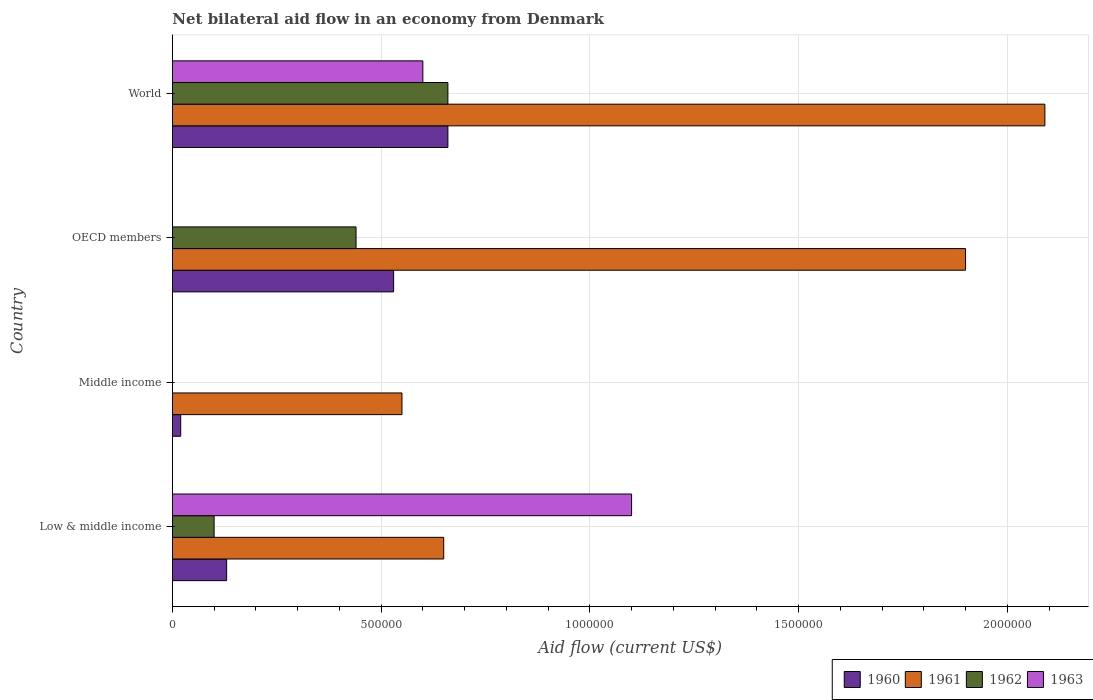How many different coloured bars are there?
Provide a succinct answer. 4. Are the number of bars on each tick of the Y-axis equal?
Provide a short and direct response. No. What is the total net bilateral aid flow in 1962 in the graph?
Your answer should be compact. 1.20e+06. What is the difference between the net bilateral aid flow in 1962 in OECD members and that in World?
Your response must be concise. -2.20e+05. What is the difference between the net bilateral aid flow in 1963 in OECD members and the net bilateral aid flow in 1961 in Middle income?
Your answer should be very brief. -5.50e+05. What is the average net bilateral aid flow in 1961 per country?
Provide a short and direct response. 1.30e+06. What is the difference between the net bilateral aid flow in 1963 and net bilateral aid flow in 1961 in World?
Offer a terse response. -1.49e+06. In how many countries, is the net bilateral aid flow in 1961 greater than 300000 US$?
Make the answer very short. 4. What is the ratio of the net bilateral aid flow in 1961 in Low & middle income to that in Middle income?
Offer a terse response. 1.18. Is the net bilateral aid flow in 1961 in Middle income less than that in World?
Keep it short and to the point. Yes. What is the difference between the highest and the second highest net bilateral aid flow in 1962?
Your answer should be very brief. 2.20e+05. What is the difference between the highest and the lowest net bilateral aid flow in 1960?
Your answer should be very brief. 6.40e+05. In how many countries, is the net bilateral aid flow in 1961 greater than the average net bilateral aid flow in 1961 taken over all countries?
Your response must be concise. 2. Is the sum of the net bilateral aid flow in 1961 in Low & middle income and World greater than the maximum net bilateral aid flow in 1962 across all countries?
Offer a very short reply. Yes. Is it the case that in every country, the sum of the net bilateral aid flow in 1963 and net bilateral aid flow in 1960 is greater than the sum of net bilateral aid flow in 1962 and net bilateral aid flow in 1961?
Give a very brief answer. No. How many countries are there in the graph?
Your answer should be very brief. 4. Are the values on the major ticks of X-axis written in scientific E-notation?
Provide a short and direct response. No. Does the graph contain any zero values?
Offer a terse response. Yes. What is the title of the graph?
Offer a terse response. Net bilateral aid flow in an economy from Denmark. What is the label or title of the Y-axis?
Provide a succinct answer. Country. What is the Aid flow (current US$) of 1960 in Low & middle income?
Ensure brevity in your answer.  1.30e+05. What is the Aid flow (current US$) in 1961 in Low & middle income?
Provide a succinct answer. 6.50e+05. What is the Aid flow (current US$) in 1963 in Low & middle income?
Your answer should be very brief. 1.10e+06. What is the Aid flow (current US$) of 1962 in Middle income?
Provide a succinct answer. 0. What is the Aid flow (current US$) of 1960 in OECD members?
Provide a succinct answer. 5.30e+05. What is the Aid flow (current US$) of 1961 in OECD members?
Keep it short and to the point. 1.90e+06. What is the Aid flow (current US$) in 1962 in OECD members?
Your answer should be very brief. 4.40e+05. What is the Aid flow (current US$) in 1961 in World?
Offer a very short reply. 2.09e+06. Across all countries, what is the maximum Aid flow (current US$) in 1960?
Keep it short and to the point. 6.60e+05. Across all countries, what is the maximum Aid flow (current US$) of 1961?
Give a very brief answer. 2.09e+06. Across all countries, what is the maximum Aid flow (current US$) of 1962?
Provide a short and direct response. 6.60e+05. Across all countries, what is the maximum Aid flow (current US$) of 1963?
Offer a terse response. 1.10e+06. Across all countries, what is the minimum Aid flow (current US$) of 1963?
Your response must be concise. 0. What is the total Aid flow (current US$) in 1960 in the graph?
Your answer should be very brief. 1.34e+06. What is the total Aid flow (current US$) in 1961 in the graph?
Your response must be concise. 5.19e+06. What is the total Aid flow (current US$) of 1962 in the graph?
Provide a succinct answer. 1.20e+06. What is the total Aid flow (current US$) in 1963 in the graph?
Your answer should be compact. 1.70e+06. What is the difference between the Aid flow (current US$) in 1960 in Low & middle income and that in Middle income?
Provide a succinct answer. 1.10e+05. What is the difference between the Aid flow (current US$) in 1960 in Low & middle income and that in OECD members?
Keep it short and to the point. -4.00e+05. What is the difference between the Aid flow (current US$) in 1961 in Low & middle income and that in OECD members?
Keep it short and to the point. -1.25e+06. What is the difference between the Aid flow (current US$) in 1960 in Low & middle income and that in World?
Provide a succinct answer. -5.30e+05. What is the difference between the Aid flow (current US$) in 1961 in Low & middle income and that in World?
Your answer should be compact. -1.44e+06. What is the difference between the Aid flow (current US$) of 1962 in Low & middle income and that in World?
Give a very brief answer. -5.60e+05. What is the difference between the Aid flow (current US$) in 1960 in Middle income and that in OECD members?
Provide a short and direct response. -5.10e+05. What is the difference between the Aid flow (current US$) in 1961 in Middle income and that in OECD members?
Offer a terse response. -1.35e+06. What is the difference between the Aid flow (current US$) in 1960 in Middle income and that in World?
Keep it short and to the point. -6.40e+05. What is the difference between the Aid flow (current US$) in 1961 in Middle income and that in World?
Keep it short and to the point. -1.54e+06. What is the difference between the Aid flow (current US$) in 1960 in OECD members and that in World?
Give a very brief answer. -1.30e+05. What is the difference between the Aid flow (current US$) of 1960 in Low & middle income and the Aid flow (current US$) of 1961 in Middle income?
Keep it short and to the point. -4.20e+05. What is the difference between the Aid flow (current US$) of 1960 in Low & middle income and the Aid flow (current US$) of 1961 in OECD members?
Make the answer very short. -1.77e+06. What is the difference between the Aid flow (current US$) of 1960 in Low & middle income and the Aid flow (current US$) of 1962 in OECD members?
Your answer should be very brief. -3.10e+05. What is the difference between the Aid flow (current US$) of 1960 in Low & middle income and the Aid flow (current US$) of 1961 in World?
Offer a terse response. -1.96e+06. What is the difference between the Aid flow (current US$) in 1960 in Low & middle income and the Aid flow (current US$) in 1962 in World?
Offer a terse response. -5.30e+05. What is the difference between the Aid flow (current US$) of 1960 in Low & middle income and the Aid flow (current US$) of 1963 in World?
Offer a terse response. -4.70e+05. What is the difference between the Aid flow (current US$) in 1961 in Low & middle income and the Aid flow (current US$) in 1962 in World?
Give a very brief answer. -10000. What is the difference between the Aid flow (current US$) of 1962 in Low & middle income and the Aid flow (current US$) of 1963 in World?
Provide a succinct answer. -5.00e+05. What is the difference between the Aid flow (current US$) of 1960 in Middle income and the Aid flow (current US$) of 1961 in OECD members?
Ensure brevity in your answer.  -1.88e+06. What is the difference between the Aid flow (current US$) in 1960 in Middle income and the Aid flow (current US$) in 1962 in OECD members?
Offer a terse response. -4.20e+05. What is the difference between the Aid flow (current US$) in 1961 in Middle income and the Aid flow (current US$) in 1962 in OECD members?
Offer a terse response. 1.10e+05. What is the difference between the Aid flow (current US$) in 1960 in Middle income and the Aid flow (current US$) in 1961 in World?
Your answer should be compact. -2.07e+06. What is the difference between the Aid flow (current US$) in 1960 in Middle income and the Aid flow (current US$) in 1962 in World?
Your answer should be compact. -6.40e+05. What is the difference between the Aid flow (current US$) of 1960 in Middle income and the Aid flow (current US$) of 1963 in World?
Offer a very short reply. -5.80e+05. What is the difference between the Aid flow (current US$) of 1961 in Middle income and the Aid flow (current US$) of 1962 in World?
Your answer should be compact. -1.10e+05. What is the difference between the Aid flow (current US$) of 1960 in OECD members and the Aid flow (current US$) of 1961 in World?
Ensure brevity in your answer.  -1.56e+06. What is the difference between the Aid flow (current US$) of 1960 in OECD members and the Aid flow (current US$) of 1962 in World?
Provide a succinct answer. -1.30e+05. What is the difference between the Aid flow (current US$) of 1961 in OECD members and the Aid flow (current US$) of 1962 in World?
Provide a short and direct response. 1.24e+06. What is the difference between the Aid flow (current US$) in 1961 in OECD members and the Aid flow (current US$) in 1963 in World?
Give a very brief answer. 1.30e+06. What is the difference between the Aid flow (current US$) in 1962 in OECD members and the Aid flow (current US$) in 1963 in World?
Give a very brief answer. -1.60e+05. What is the average Aid flow (current US$) of 1960 per country?
Your answer should be very brief. 3.35e+05. What is the average Aid flow (current US$) in 1961 per country?
Ensure brevity in your answer.  1.30e+06. What is the average Aid flow (current US$) of 1962 per country?
Offer a terse response. 3.00e+05. What is the average Aid flow (current US$) of 1963 per country?
Your answer should be compact. 4.25e+05. What is the difference between the Aid flow (current US$) in 1960 and Aid flow (current US$) in 1961 in Low & middle income?
Your answer should be compact. -5.20e+05. What is the difference between the Aid flow (current US$) in 1960 and Aid flow (current US$) in 1963 in Low & middle income?
Make the answer very short. -9.70e+05. What is the difference between the Aid flow (current US$) of 1961 and Aid flow (current US$) of 1963 in Low & middle income?
Keep it short and to the point. -4.50e+05. What is the difference between the Aid flow (current US$) of 1960 and Aid flow (current US$) of 1961 in Middle income?
Make the answer very short. -5.30e+05. What is the difference between the Aid flow (current US$) of 1960 and Aid flow (current US$) of 1961 in OECD members?
Offer a very short reply. -1.37e+06. What is the difference between the Aid flow (current US$) of 1961 and Aid flow (current US$) of 1962 in OECD members?
Provide a short and direct response. 1.46e+06. What is the difference between the Aid flow (current US$) of 1960 and Aid flow (current US$) of 1961 in World?
Ensure brevity in your answer.  -1.43e+06. What is the difference between the Aid flow (current US$) of 1961 and Aid flow (current US$) of 1962 in World?
Ensure brevity in your answer.  1.43e+06. What is the difference between the Aid flow (current US$) of 1961 and Aid flow (current US$) of 1963 in World?
Provide a succinct answer. 1.49e+06. What is the ratio of the Aid flow (current US$) in 1961 in Low & middle income to that in Middle income?
Ensure brevity in your answer.  1.18. What is the ratio of the Aid flow (current US$) in 1960 in Low & middle income to that in OECD members?
Your answer should be compact. 0.25. What is the ratio of the Aid flow (current US$) of 1961 in Low & middle income to that in OECD members?
Give a very brief answer. 0.34. What is the ratio of the Aid flow (current US$) in 1962 in Low & middle income to that in OECD members?
Your answer should be very brief. 0.23. What is the ratio of the Aid flow (current US$) of 1960 in Low & middle income to that in World?
Offer a terse response. 0.2. What is the ratio of the Aid flow (current US$) of 1961 in Low & middle income to that in World?
Your answer should be compact. 0.31. What is the ratio of the Aid flow (current US$) of 1962 in Low & middle income to that in World?
Your answer should be very brief. 0.15. What is the ratio of the Aid flow (current US$) in 1963 in Low & middle income to that in World?
Your response must be concise. 1.83. What is the ratio of the Aid flow (current US$) in 1960 in Middle income to that in OECD members?
Keep it short and to the point. 0.04. What is the ratio of the Aid flow (current US$) in 1961 in Middle income to that in OECD members?
Offer a very short reply. 0.29. What is the ratio of the Aid flow (current US$) of 1960 in Middle income to that in World?
Ensure brevity in your answer.  0.03. What is the ratio of the Aid flow (current US$) of 1961 in Middle income to that in World?
Your answer should be very brief. 0.26. What is the ratio of the Aid flow (current US$) in 1960 in OECD members to that in World?
Give a very brief answer. 0.8. What is the ratio of the Aid flow (current US$) in 1961 in OECD members to that in World?
Your answer should be very brief. 0.91. What is the difference between the highest and the second highest Aid flow (current US$) in 1960?
Provide a succinct answer. 1.30e+05. What is the difference between the highest and the second highest Aid flow (current US$) in 1961?
Your response must be concise. 1.90e+05. What is the difference between the highest and the lowest Aid flow (current US$) of 1960?
Provide a short and direct response. 6.40e+05. What is the difference between the highest and the lowest Aid flow (current US$) in 1961?
Give a very brief answer. 1.54e+06. What is the difference between the highest and the lowest Aid flow (current US$) in 1963?
Offer a terse response. 1.10e+06. 